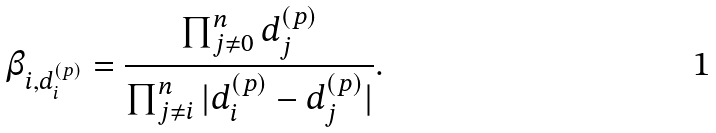<formula> <loc_0><loc_0><loc_500><loc_500>\beta _ { i , d ^ { ( p ) } _ { i } } = \frac { \prod _ { j \ne 0 } ^ { n } d ^ { ( p ) } _ { j } } { \prod _ { j \ne i } ^ { n } | d ^ { ( p ) } _ { i } - d ^ { ( p ) } _ { j } | } .</formula> 